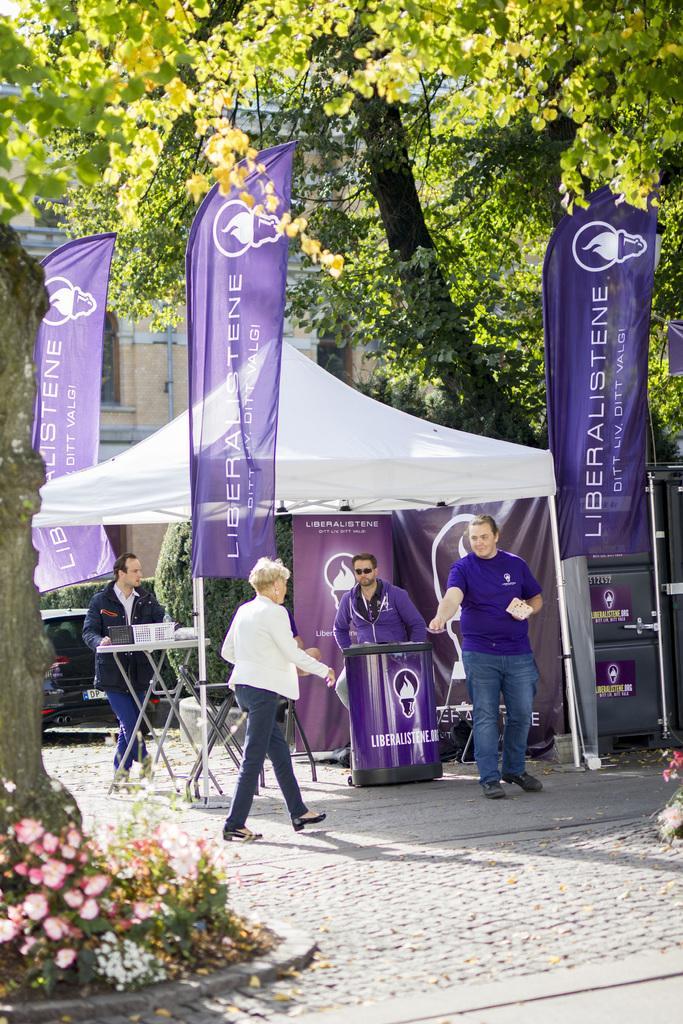Please provide a concise description of this image. In the center of the image we can see the boards, tent, tables, some persons. On the tables we can see some objects. In the background of the image we can see the trees, building, pipe, window, wall, car. At the bottom of the image we can see the ground, flowers, plants. 